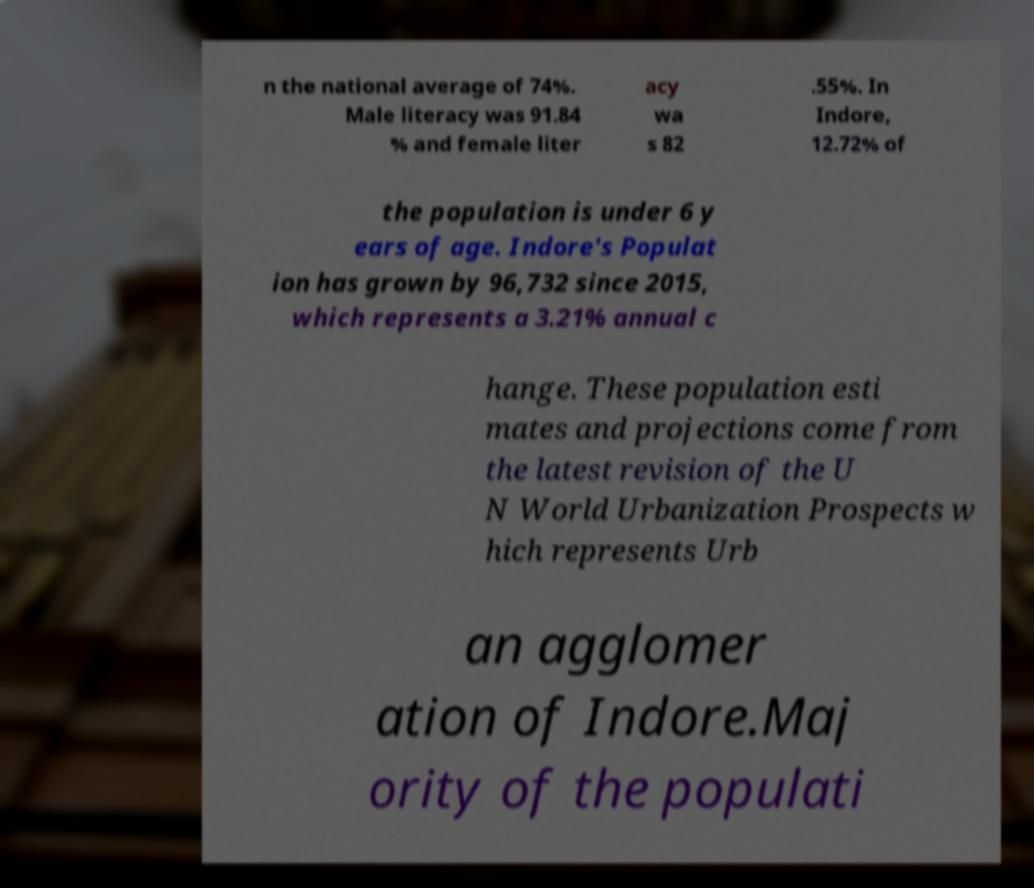Can you accurately transcribe the text from the provided image for me? n the national average of 74%. Male literacy was 91.84 % and female liter acy wa s 82 .55%. In Indore, 12.72% of the population is under 6 y ears of age. Indore's Populat ion has grown by 96,732 since 2015, which represents a 3.21% annual c hange. These population esti mates and projections come from the latest revision of the U N World Urbanization Prospects w hich represents Urb an agglomer ation of Indore.Maj ority of the populati 